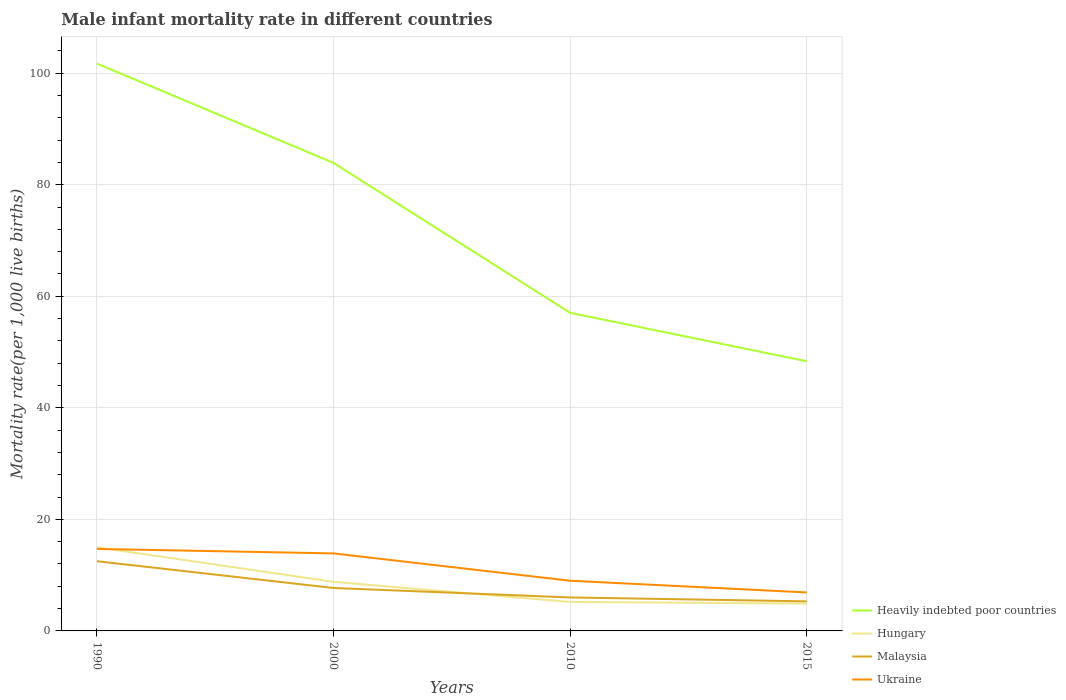Does the line corresponding to Malaysia intersect with the line corresponding to Hungary?
Ensure brevity in your answer.  Yes. Is the number of lines equal to the number of legend labels?
Provide a succinct answer. Yes. In which year was the male infant mortality rate in Ukraine maximum?
Your answer should be compact. 2015. What is the total male infant mortality rate in Malaysia in the graph?
Your answer should be compact. 0.7. Is the male infant mortality rate in Heavily indebted poor countries strictly greater than the male infant mortality rate in Ukraine over the years?
Ensure brevity in your answer.  No. What is the difference between two consecutive major ticks on the Y-axis?
Keep it short and to the point. 20. Does the graph contain any zero values?
Provide a succinct answer. No. How many legend labels are there?
Keep it short and to the point. 4. How are the legend labels stacked?
Your answer should be very brief. Vertical. What is the title of the graph?
Your response must be concise. Male infant mortality rate in different countries. Does "Belgium" appear as one of the legend labels in the graph?
Make the answer very short. No. What is the label or title of the X-axis?
Keep it short and to the point. Years. What is the label or title of the Y-axis?
Ensure brevity in your answer.  Mortality rate(per 1,0 live births). What is the Mortality rate(per 1,000 live births) of Heavily indebted poor countries in 1990?
Ensure brevity in your answer.  101.73. What is the Mortality rate(per 1,000 live births) of Hungary in 1990?
Provide a short and direct response. 15. What is the Mortality rate(per 1,000 live births) of Malaysia in 1990?
Offer a terse response. 12.5. What is the Mortality rate(per 1,000 live births) of Ukraine in 1990?
Offer a very short reply. 14.7. What is the Mortality rate(per 1,000 live births) in Heavily indebted poor countries in 2000?
Provide a short and direct response. 83.92. What is the Mortality rate(per 1,000 live births) in Hungary in 2000?
Make the answer very short. 8.8. What is the Mortality rate(per 1,000 live births) in Malaysia in 2000?
Offer a very short reply. 7.7. What is the Mortality rate(per 1,000 live births) in Ukraine in 2000?
Your answer should be compact. 13.9. What is the Mortality rate(per 1,000 live births) in Heavily indebted poor countries in 2010?
Keep it short and to the point. 57.04. What is the Mortality rate(per 1,000 live births) of Hungary in 2010?
Keep it short and to the point. 5.2. What is the Mortality rate(per 1,000 live births) in Malaysia in 2010?
Keep it short and to the point. 6. What is the Mortality rate(per 1,000 live births) of Ukraine in 2010?
Offer a terse response. 9. What is the Mortality rate(per 1,000 live births) in Heavily indebted poor countries in 2015?
Ensure brevity in your answer.  48.35. Across all years, what is the maximum Mortality rate(per 1,000 live births) of Heavily indebted poor countries?
Your answer should be very brief. 101.73. Across all years, what is the minimum Mortality rate(per 1,000 live births) of Heavily indebted poor countries?
Ensure brevity in your answer.  48.35. What is the total Mortality rate(per 1,000 live births) of Heavily indebted poor countries in the graph?
Your answer should be very brief. 291.03. What is the total Mortality rate(per 1,000 live births) of Hungary in the graph?
Ensure brevity in your answer.  33.9. What is the total Mortality rate(per 1,000 live births) in Malaysia in the graph?
Keep it short and to the point. 31.5. What is the total Mortality rate(per 1,000 live births) in Ukraine in the graph?
Make the answer very short. 44.5. What is the difference between the Mortality rate(per 1,000 live births) of Heavily indebted poor countries in 1990 and that in 2000?
Your answer should be very brief. 17.81. What is the difference between the Mortality rate(per 1,000 live births) of Malaysia in 1990 and that in 2000?
Make the answer very short. 4.8. What is the difference between the Mortality rate(per 1,000 live births) of Ukraine in 1990 and that in 2000?
Make the answer very short. 0.8. What is the difference between the Mortality rate(per 1,000 live births) of Heavily indebted poor countries in 1990 and that in 2010?
Provide a short and direct response. 44.69. What is the difference between the Mortality rate(per 1,000 live births) in Hungary in 1990 and that in 2010?
Ensure brevity in your answer.  9.8. What is the difference between the Mortality rate(per 1,000 live births) of Malaysia in 1990 and that in 2010?
Offer a very short reply. 6.5. What is the difference between the Mortality rate(per 1,000 live births) of Heavily indebted poor countries in 1990 and that in 2015?
Your answer should be very brief. 53.38. What is the difference between the Mortality rate(per 1,000 live births) in Hungary in 1990 and that in 2015?
Provide a succinct answer. 10.1. What is the difference between the Mortality rate(per 1,000 live births) in Malaysia in 1990 and that in 2015?
Your response must be concise. 7.2. What is the difference between the Mortality rate(per 1,000 live births) in Ukraine in 1990 and that in 2015?
Your answer should be very brief. 7.8. What is the difference between the Mortality rate(per 1,000 live births) of Heavily indebted poor countries in 2000 and that in 2010?
Ensure brevity in your answer.  26.88. What is the difference between the Mortality rate(per 1,000 live births) of Hungary in 2000 and that in 2010?
Offer a very short reply. 3.6. What is the difference between the Mortality rate(per 1,000 live births) in Malaysia in 2000 and that in 2010?
Keep it short and to the point. 1.7. What is the difference between the Mortality rate(per 1,000 live births) in Ukraine in 2000 and that in 2010?
Your response must be concise. 4.9. What is the difference between the Mortality rate(per 1,000 live births) in Heavily indebted poor countries in 2000 and that in 2015?
Keep it short and to the point. 35.57. What is the difference between the Mortality rate(per 1,000 live births) in Hungary in 2000 and that in 2015?
Your response must be concise. 3.9. What is the difference between the Mortality rate(per 1,000 live births) of Malaysia in 2000 and that in 2015?
Offer a terse response. 2.4. What is the difference between the Mortality rate(per 1,000 live births) in Ukraine in 2000 and that in 2015?
Keep it short and to the point. 7. What is the difference between the Mortality rate(per 1,000 live births) of Heavily indebted poor countries in 2010 and that in 2015?
Your response must be concise. 8.69. What is the difference between the Mortality rate(per 1,000 live births) of Heavily indebted poor countries in 1990 and the Mortality rate(per 1,000 live births) of Hungary in 2000?
Ensure brevity in your answer.  92.93. What is the difference between the Mortality rate(per 1,000 live births) of Heavily indebted poor countries in 1990 and the Mortality rate(per 1,000 live births) of Malaysia in 2000?
Offer a very short reply. 94.03. What is the difference between the Mortality rate(per 1,000 live births) in Heavily indebted poor countries in 1990 and the Mortality rate(per 1,000 live births) in Ukraine in 2000?
Keep it short and to the point. 87.83. What is the difference between the Mortality rate(per 1,000 live births) of Hungary in 1990 and the Mortality rate(per 1,000 live births) of Malaysia in 2000?
Give a very brief answer. 7.3. What is the difference between the Mortality rate(per 1,000 live births) of Heavily indebted poor countries in 1990 and the Mortality rate(per 1,000 live births) of Hungary in 2010?
Your answer should be compact. 96.53. What is the difference between the Mortality rate(per 1,000 live births) in Heavily indebted poor countries in 1990 and the Mortality rate(per 1,000 live births) in Malaysia in 2010?
Offer a terse response. 95.73. What is the difference between the Mortality rate(per 1,000 live births) in Heavily indebted poor countries in 1990 and the Mortality rate(per 1,000 live births) in Ukraine in 2010?
Give a very brief answer. 92.73. What is the difference between the Mortality rate(per 1,000 live births) of Hungary in 1990 and the Mortality rate(per 1,000 live births) of Malaysia in 2010?
Your answer should be compact. 9. What is the difference between the Mortality rate(per 1,000 live births) of Hungary in 1990 and the Mortality rate(per 1,000 live births) of Ukraine in 2010?
Provide a succinct answer. 6. What is the difference between the Mortality rate(per 1,000 live births) in Heavily indebted poor countries in 1990 and the Mortality rate(per 1,000 live births) in Hungary in 2015?
Offer a very short reply. 96.83. What is the difference between the Mortality rate(per 1,000 live births) in Heavily indebted poor countries in 1990 and the Mortality rate(per 1,000 live births) in Malaysia in 2015?
Keep it short and to the point. 96.43. What is the difference between the Mortality rate(per 1,000 live births) in Heavily indebted poor countries in 1990 and the Mortality rate(per 1,000 live births) in Ukraine in 2015?
Offer a very short reply. 94.83. What is the difference between the Mortality rate(per 1,000 live births) of Hungary in 1990 and the Mortality rate(per 1,000 live births) of Malaysia in 2015?
Provide a short and direct response. 9.7. What is the difference between the Mortality rate(per 1,000 live births) of Heavily indebted poor countries in 2000 and the Mortality rate(per 1,000 live births) of Hungary in 2010?
Provide a short and direct response. 78.72. What is the difference between the Mortality rate(per 1,000 live births) of Heavily indebted poor countries in 2000 and the Mortality rate(per 1,000 live births) of Malaysia in 2010?
Your answer should be compact. 77.92. What is the difference between the Mortality rate(per 1,000 live births) in Heavily indebted poor countries in 2000 and the Mortality rate(per 1,000 live births) in Ukraine in 2010?
Your answer should be compact. 74.92. What is the difference between the Mortality rate(per 1,000 live births) in Heavily indebted poor countries in 2000 and the Mortality rate(per 1,000 live births) in Hungary in 2015?
Your response must be concise. 79.02. What is the difference between the Mortality rate(per 1,000 live births) in Heavily indebted poor countries in 2000 and the Mortality rate(per 1,000 live births) in Malaysia in 2015?
Your response must be concise. 78.62. What is the difference between the Mortality rate(per 1,000 live births) of Heavily indebted poor countries in 2000 and the Mortality rate(per 1,000 live births) of Ukraine in 2015?
Give a very brief answer. 77.02. What is the difference between the Mortality rate(per 1,000 live births) in Malaysia in 2000 and the Mortality rate(per 1,000 live births) in Ukraine in 2015?
Your answer should be very brief. 0.8. What is the difference between the Mortality rate(per 1,000 live births) in Heavily indebted poor countries in 2010 and the Mortality rate(per 1,000 live births) in Hungary in 2015?
Give a very brief answer. 52.14. What is the difference between the Mortality rate(per 1,000 live births) of Heavily indebted poor countries in 2010 and the Mortality rate(per 1,000 live births) of Malaysia in 2015?
Your answer should be very brief. 51.74. What is the difference between the Mortality rate(per 1,000 live births) in Heavily indebted poor countries in 2010 and the Mortality rate(per 1,000 live births) in Ukraine in 2015?
Offer a terse response. 50.14. What is the difference between the Mortality rate(per 1,000 live births) of Hungary in 2010 and the Mortality rate(per 1,000 live births) of Malaysia in 2015?
Give a very brief answer. -0.1. What is the average Mortality rate(per 1,000 live births) in Heavily indebted poor countries per year?
Keep it short and to the point. 72.76. What is the average Mortality rate(per 1,000 live births) of Hungary per year?
Offer a terse response. 8.47. What is the average Mortality rate(per 1,000 live births) in Malaysia per year?
Provide a short and direct response. 7.88. What is the average Mortality rate(per 1,000 live births) in Ukraine per year?
Offer a very short reply. 11.12. In the year 1990, what is the difference between the Mortality rate(per 1,000 live births) in Heavily indebted poor countries and Mortality rate(per 1,000 live births) in Hungary?
Offer a very short reply. 86.73. In the year 1990, what is the difference between the Mortality rate(per 1,000 live births) in Heavily indebted poor countries and Mortality rate(per 1,000 live births) in Malaysia?
Make the answer very short. 89.23. In the year 1990, what is the difference between the Mortality rate(per 1,000 live births) in Heavily indebted poor countries and Mortality rate(per 1,000 live births) in Ukraine?
Give a very brief answer. 87.03. In the year 1990, what is the difference between the Mortality rate(per 1,000 live births) of Hungary and Mortality rate(per 1,000 live births) of Malaysia?
Give a very brief answer. 2.5. In the year 1990, what is the difference between the Mortality rate(per 1,000 live births) in Hungary and Mortality rate(per 1,000 live births) in Ukraine?
Ensure brevity in your answer.  0.3. In the year 2000, what is the difference between the Mortality rate(per 1,000 live births) of Heavily indebted poor countries and Mortality rate(per 1,000 live births) of Hungary?
Keep it short and to the point. 75.12. In the year 2000, what is the difference between the Mortality rate(per 1,000 live births) of Heavily indebted poor countries and Mortality rate(per 1,000 live births) of Malaysia?
Make the answer very short. 76.22. In the year 2000, what is the difference between the Mortality rate(per 1,000 live births) of Heavily indebted poor countries and Mortality rate(per 1,000 live births) of Ukraine?
Your answer should be compact. 70.02. In the year 2000, what is the difference between the Mortality rate(per 1,000 live births) of Hungary and Mortality rate(per 1,000 live births) of Malaysia?
Offer a very short reply. 1.1. In the year 2000, what is the difference between the Mortality rate(per 1,000 live births) of Malaysia and Mortality rate(per 1,000 live births) of Ukraine?
Keep it short and to the point. -6.2. In the year 2010, what is the difference between the Mortality rate(per 1,000 live births) in Heavily indebted poor countries and Mortality rate(per 1,000 live births) in Hungary?
Offer a very short reply. 51.84. In the year 2010, what is the difference between the Mortality rate(per 1,000 live births) of Heavily indebted poor countries and Mortality rate(per 1,000 live births) of Malaysia?
Give a very brief answer. 51.04. In the year 2010, what is the difference between the Mortality rate(per 1,000 live births) of Heavily indebted poor countries and Mortality rate(per 1,000 live births) of Ukraine?
Ensure brevity in your answer.  48.04. In the year 2015, what is the difference between the Mortality rate(per 1,000 live births) of Heavily indebted poor countries and Mortality rate(per 1,000 live births) of Hungary?
Provide a succinct answer. 43.45. In the year 2015, what is the difference between the Mortality rate(per 1,000 live births) of Heavily indebted poor countries and Mortality rate(per 1,000 live births) of Malaysia?
Your response must be concise. 43.05. In the year 2015, what is the difference between the Mortality rate(per 1,000 live births) in Heavily indebted poor countries and Mortality rate(per 1,000 live births) in Ukraine?
Offer a terse response. 41.45. In the year 2015, what is the difference between the Mortality rate(per 1,000 live births) of Hungary and Mortality rate(per 1,000 live births) of Malaysia?
Your answer should be very brief. -0.4. In the year 2015, what is the difference between the Mortality rate(per 1,000 live births) in Hungary and Mortality rate(per 1,000 live births) in Ukraine?
Your answer should be compact. -2. What is the ratio of the Mortality rate(per 1,000 live births) in Heavily indebted poor countries in 1990 to that in 2000?
Make the answer very short. 1.21. What is the ratio of the Mortality rate(per 1,000 live births) in Hungary in 1990 to that in 2000?
Ensure brevity in your answer.  1.7. What is the ratio of the Mortality rate(per 1,000 live births) in Malaysia in 1990 to that in 2000?
Your response must be concise. 1.62. What is the ratio of the Mortality rate(per 1,000 live births) in Ukraine in 1990 to that in 2000?
Your answer should be compact. 1.06. What is the ratio of the Mortality rate(per 1,000 live births) in Heavily indebted poor countries in 1990 to that in 2010?
Your answer should be compact. 1.78. What is the ratio of the Mortality rate(per 1,000 live births) of Hungary in 1990 to that in 2010?
Keep it short and to the point. 2.88. What is the ratio of the Mortality rate(per 1,000 live births) of Malaysia in 1990 to that in 2010?
Give a very brief answer. 2.08. What is the ratio of the Mortality rate(per 1,000 live births) in Ukraine in 1990 to that in 2010?
Offer a terse response. 1.63. What is the ratio of the Mortality rate(per 1,000 live births) in Heavily indebted poor countries in 1990 to that in 2015?
Provide a succinct answer. 2.1. What is the ratio of the Mortality rate(per 1,000 live births) of Hungary in 1990 to that in 2015?
Keep it short and to the point. 3.06. What is the ratio of the Mortality rate(per 1,000 live births) in Malaysia in 1990 to that in 2015?
Make the answer very short. 2.36. What is the ratio of the Mortality rate(per 1,000 live births) in Ukraine in 1990 to that in 2015?
Offer a very short reply. 2.13. What is the ratio of the Mortality rate(per 1,000 live births) of Heavily indebted poor countries in 2000 to that in 2010?
Your answer should be compact. 1.47. What is the ratio of the Mortality rate(per 1,000 live births) in Hungary in 2000 to that in 2010?
Offer a very short reply. 1.69. What is the ratio of the Mortality rate(per 1,000 live births) of Malaysia in 2000 to that in 2010?
Your response must be concise. 1.28. What is the ratio of the Mortality rate(per 1,000 live births) of Ukraine in 2000 to that in 2010?
Ensure brevity in your answer.  1.54. What is the ratio of the Mortality rate(per 1,000 live births) in Heavily indebted poor countries in 2000 to that in 2015?
Make the answer very short. 1.74. What is the ratio of the Mortality rate(per 1,000 live births) of Hungary in 2000 to that in 2015?
Ensure brevity in your answer.  1.8. What is the ratio of the Mortality rate(per 1,000 live births) of Malaysia in 2000 to that in 2015?
Provide a succinct answer. 1.45. What is the ratio of the Mortality rate(per 1,000 live births) of Ukraine in 2000 to that in 2015?
Provide a short and direct response. 2.01. What is the ratio of the Mortality rate(per 1,000 live births) of Heavily indebted poor countries in 2010 to that in 2015?
Provide a short and direct response. 1.18. What is the ratio of the Mortality rate(per 1,000 live births) in Hungary in 2010 to that in 2015?
Make the answer very short. 1.06. What is the ratio of the Mortality rate(per 1,000 live births) in Malaysia in 2010 to that in 2015?
Provide a short and direct response. 1.13. What is the ratio of the Mortality rate(per 1,000 live births) of Ukraine in 2010 to that in 2015?
Ensure brevity in your answer.  1.3. What is the difference between the highest and the second highest Mortality rate(per 1,000 live births) of Heavily indebted poor countries?
Your response must be concise. 17.81. What is the difference between the highest and the lowest Mortality rate(per 1,000 live births) in Heavily indebted poor countries?
Offer a very short reply. 53.38. What is the difference between the highest and the lowest Mortality rate(per 1,000 live births) of Hungary?
Offer a very short reply. 10.1. What is the difference between the highest and the lowest Mortality rate(per 1,000 live births) of Ukraine?
Your answer should be compact. 7.8. 